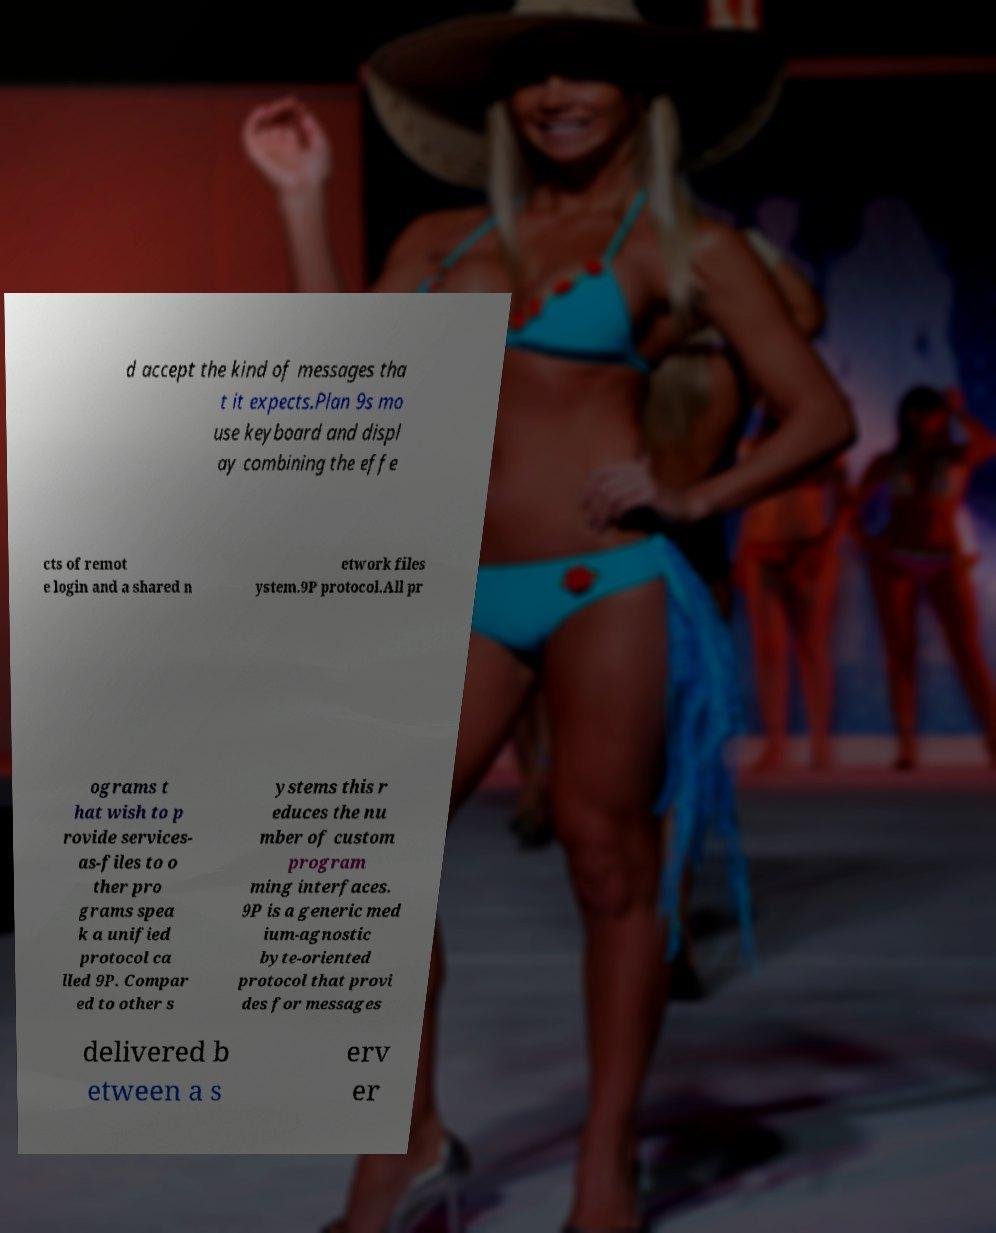Can you accurately transcribe the text from the provided image for me? d accept the kind of messages tha t it expects.Plan 9s mo use keyboard and displ ay combining the effe cts of remot e login and a shared n etwork files ystem.9P protocol.All pr ograms t hat wish to p rovide services- as-files to o ther pro grams spea k a unified protocol ca lled 9P. Compar ed to other s ystems this r educes the nu mber of custom program ming interfaces. 9P is a generic med ium-agnostic byte-oriented protocol that provi des for messages delivered b etween a s erv er 